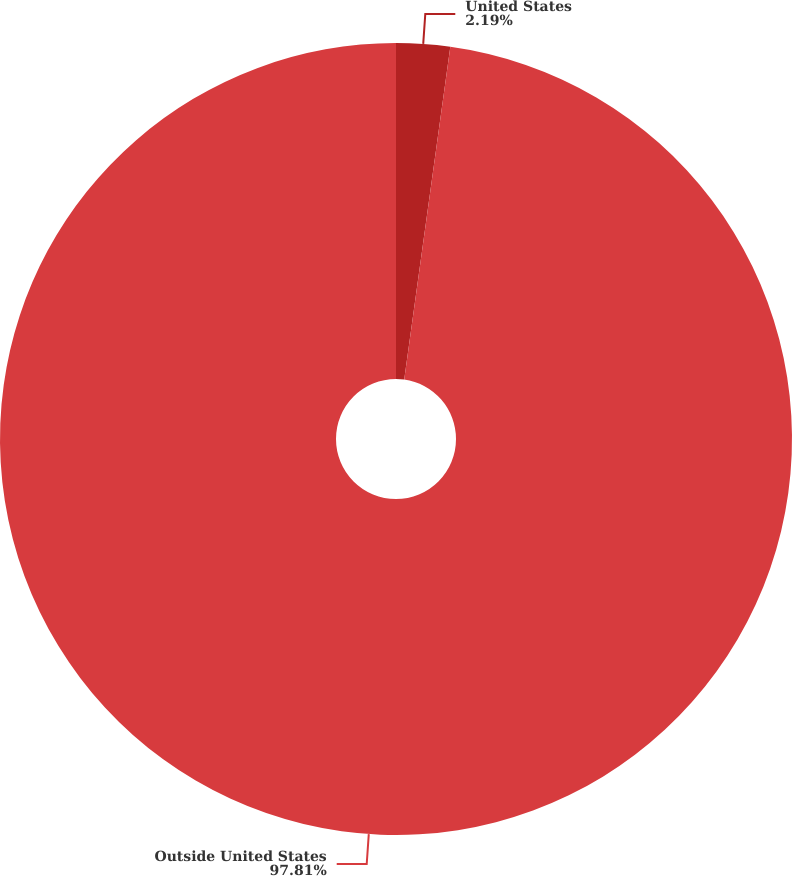Convert chart to OTSL. <chart><loc_0><loc_0><loc_500><loc_500><pie_chart><fcel>United States<fcel>Outside United States<nl><fcel>2.19%<fcel>97.81%<nl></chart> 